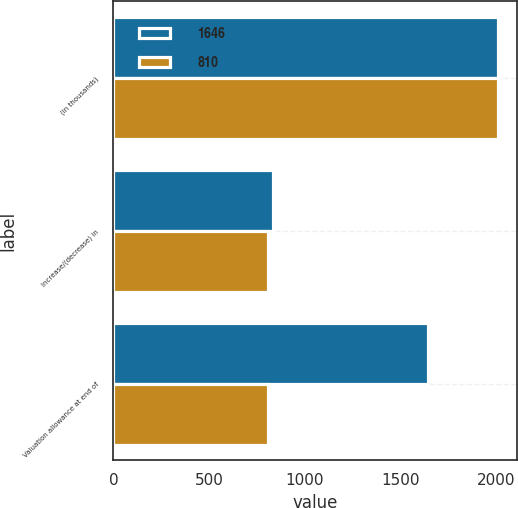<chart> <loc_0><loc_0><loc_500><loc_500><stacked_bar_chart><ecel><fcel>(in thousands)<fcel>Increase/(decrease) in<fcel>Valuation allowance at end of<nl><fcel>1646<fcel>2011<fcel>836<fcel>1646<nl><fcel>810<fcel>2010<fcel>810<fcel>810<nl></chart> 